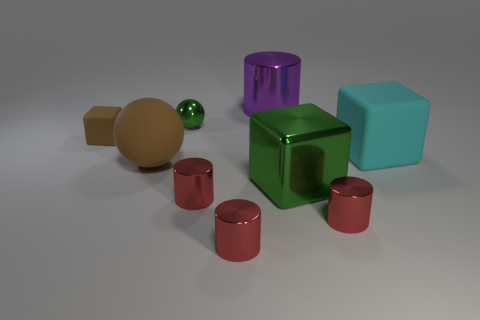Do the tiny block and the big cyan object have the same material?
Make the answer very short. Yes. There is a rubber thing that is on the right side of the metal cylinder behind the tiny rubber block; what shape is it?
Ensure brevity in your answer.  Cube. There is a green metal object behind the green block; how many red cylinders are on the right side of it?
Your answer should be compact. 3. There is a large object that is to the right of the purple metallic thing and in front of the big rubber cube; what material is it?
Your response must be concise. Metal. The brown matte object that is the same size as the metallic cube is what shape?
Keep it short and to the point. Sphere. What color is the tiny object that is behind the brown thing that is behind the large cube behind the matte ball?
Offer a terse response. Green. What number of things are matte things that are behind the large cyan matte cube or tiny green things?
Make the answer very short. 2. What is the material of the other cube that is the same size as the metal block?
Keep it short and to the point. Rubber. What material is the cylinder that is to the left of the metal thing in front of the tiny red thing to the right of the large shiny cube?
Offer a very short reply. Metal. The big rubber sphere is what color?
Make the answer very short. Brown. 